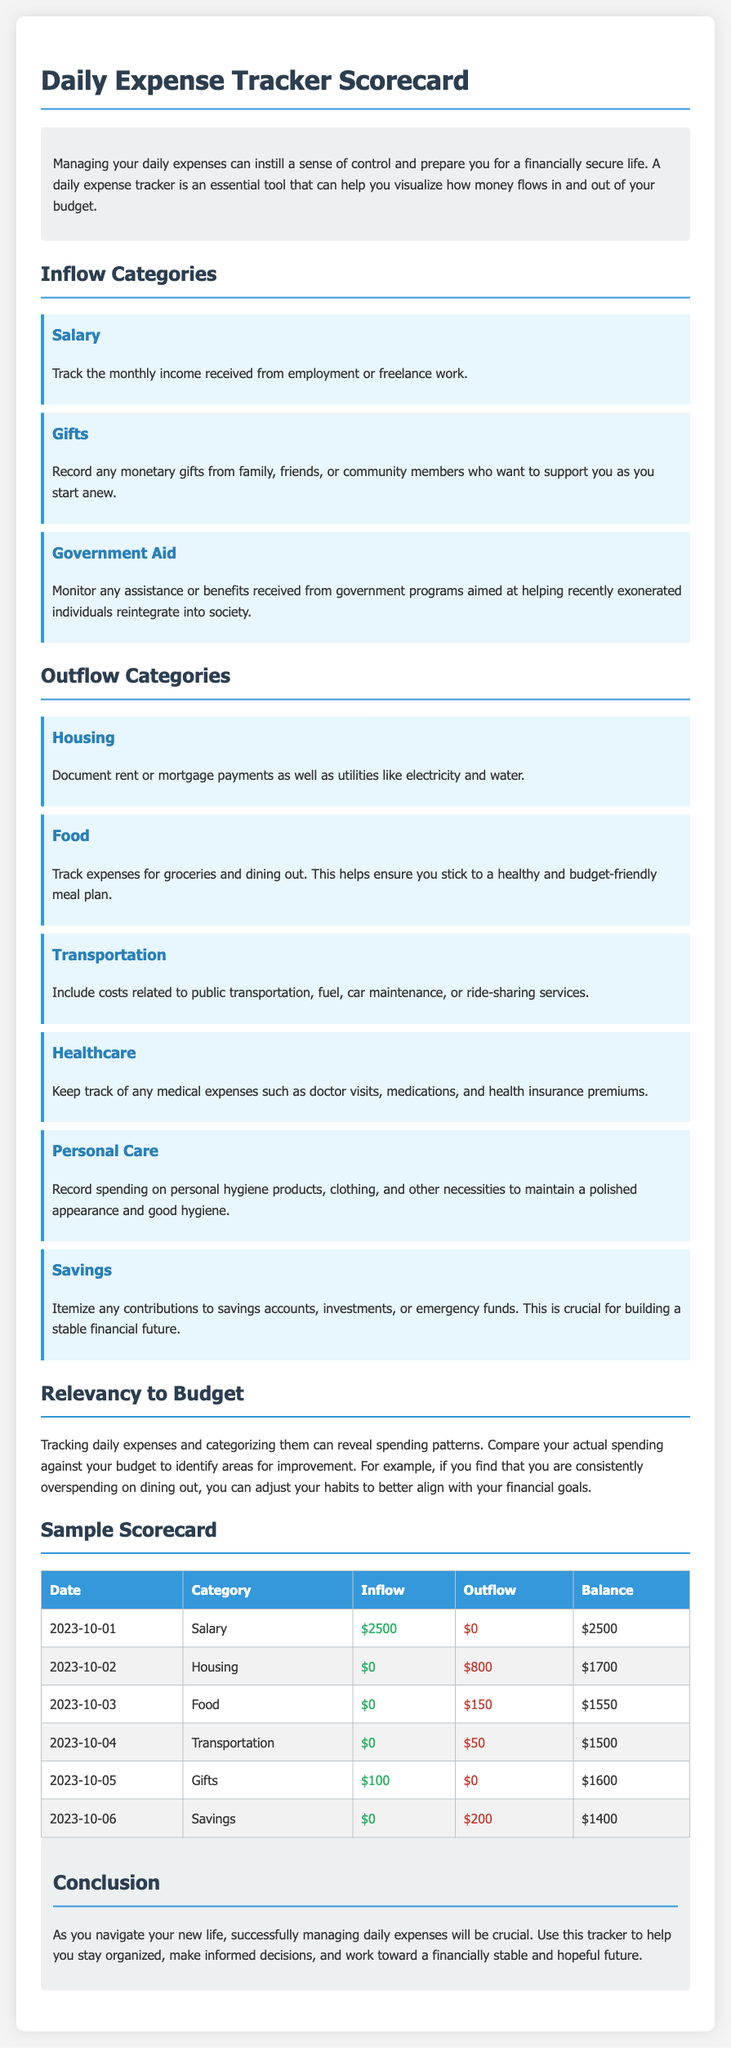what is the total inflow from Salary? The inflow from Salary is listed as $2500 on October 1, 2023.
Answer: $2500 what is the outflow for Housing? The outflow for Housing is recorded as $800 on October 2, 2023.
Answer: $800 how much was spent on Food? The amount spent on Food is $150 on October 3, 2023.
Answer: $150 what is the balance after the first entry? The balance after the first entry is $2500 on October 1, 2023.
Answer: $2500 which inflow category includes monetary gifts? The inflow category for monetary gifts is Gifts.
Answer: Gifts which outflow category is related to daily necessities? The outflow category related to daily necessities is Personal Care.
Answer: Personal Care how many categories are there for inflow? There are three categories for inflow: Salary, Gifts, and Government Aid.
Answer: Three what was the total outflow in the sample scorecard? The total outflow calculated from the sample scorecard amounts to $1,200.
Answer: $1200 what is the purpose of the daily expense tracker? The purpose is to manage daily expenses and visualize cash flow in and out of the budget.
Answer: Manage daily expenses 